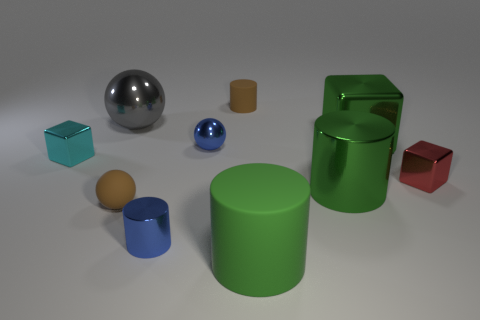The brown matte ball is what size?
Offer a terse response. Small. Is the number of brown rubber objects that are behind the tiny cyan metallic block greater than the number of rubber spheres that are on the right side of the big shiny block?
Make the answer very short. Yes. Are there any large shiny spheres in front of the large metal ball?
Offer a terse response. No. Is there a gray metal object that has the same size as the red object?
Keep it short and to the point. No. There is a small ball that is the same material as the cyan cube; what is its color?
Ensure brevity in your answer.  Blue. What is the green block made of?
Provide a succinct answer. Metal. What is the shape of the gray object?
Your answer should be very brief. Sphere. What number of tiny metal things have the same color as the tiny metal ball?
Give a very brief answer. 1. There is a small brown thing that is behind the cube behind the tiny ball behind the cyan object; what is it made of?
Provide a short and direct response. Rubber. What number of gray things are small rubber cylinders or small rubber balls?
Your response must be concise. 0. 